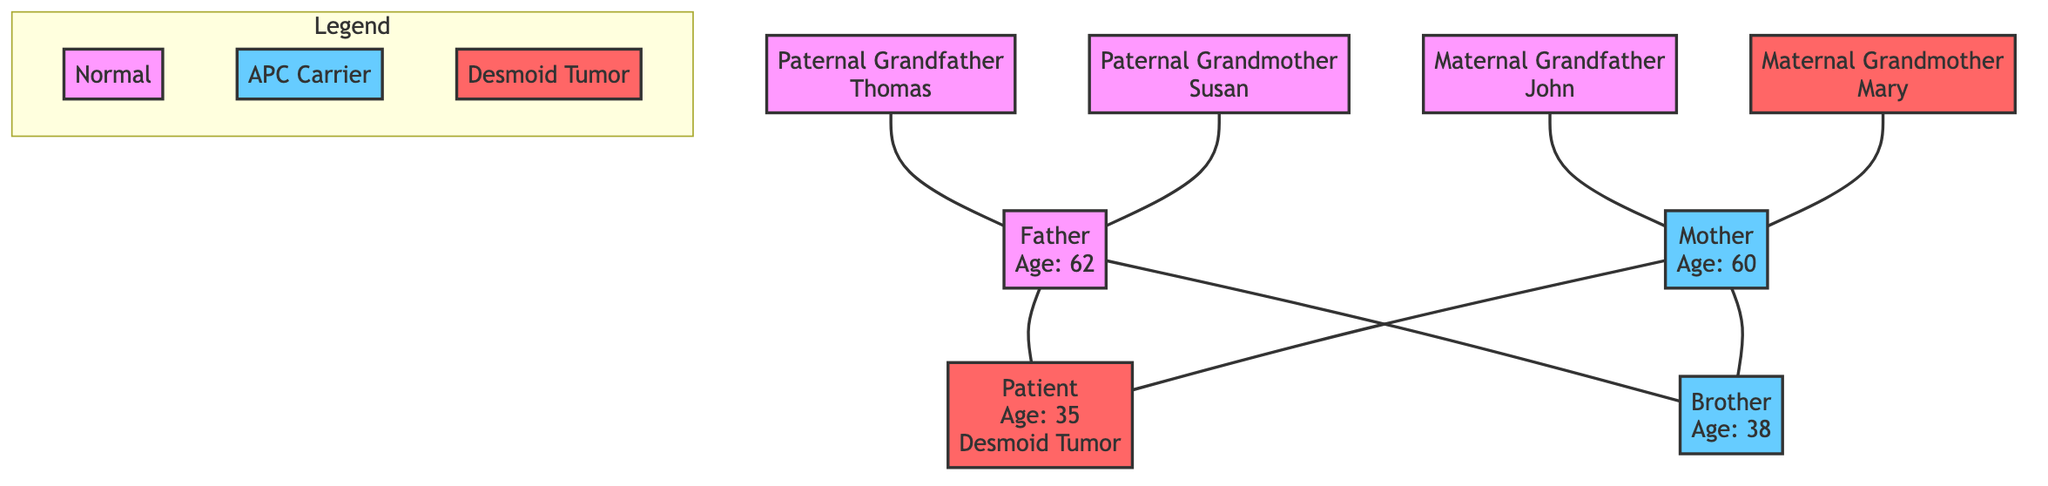What is the age of the patient? The diagram indicates that the patient is 35 years old, as specified in their node.
Answer: 35 How many carriers of the APC gene mutation are there in the patient’s immediate family? The patient’s immediate family includes the mother and brother, both of whom have the APC gene mutation, contributing to a total of two carriers.
Answer: 2 Who in the family has a history of desmoid tumors? The only family member with a history of desmoid tumors is the maternal grandmother, Mary, as denoted in her node.
Answer: Mary What is the relation of John to the patient? John is identified as the maternal grandfather in the diagram, establishing his relationship to the patient through the mother.
Answer: Maternal Grandfather What is the genetic status of the patient's father? The father is indicated in the diagram as having no genetic markers linked to desmoid tumors, which suggests he is not a carrier of the APC mutation.
Answer: Normal How many generations are represented in the family tree? The diagram depicts three generations: grandparents, parents, and the patient and sibling. Counting each distinct generation gives a total of three.
Answer: 3 Which family member is the oldest? Among the family members, the maternal grandmother, Mary, is marked as 60 years old, which is the highest age in the presented information.
Answer: 60 Is there any history of desmoid tumors in the paternal side of the family? According to the diagram, none of the paternal relatives (grandfather Thomas and grandmother Susan) are noted to have a history of desmoid tumors, indicating no relevant cases.
Answer: No Which sibling is a carrier of the APC gene mutation? The brother of the patient is mentioned in the diagram as a carrier of the APC gene mutation.
Answer: Brother 